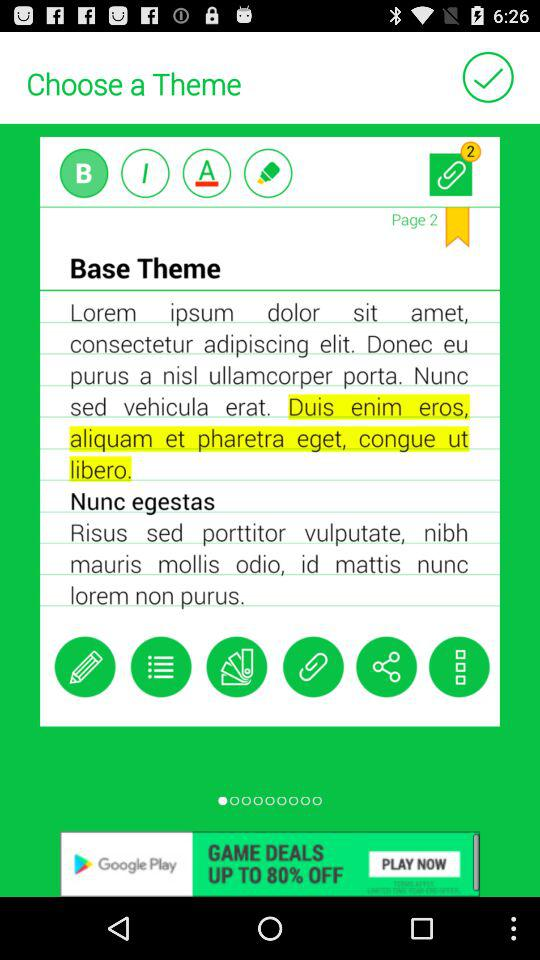What page number is shown on the screen? The shown page number is 2. 